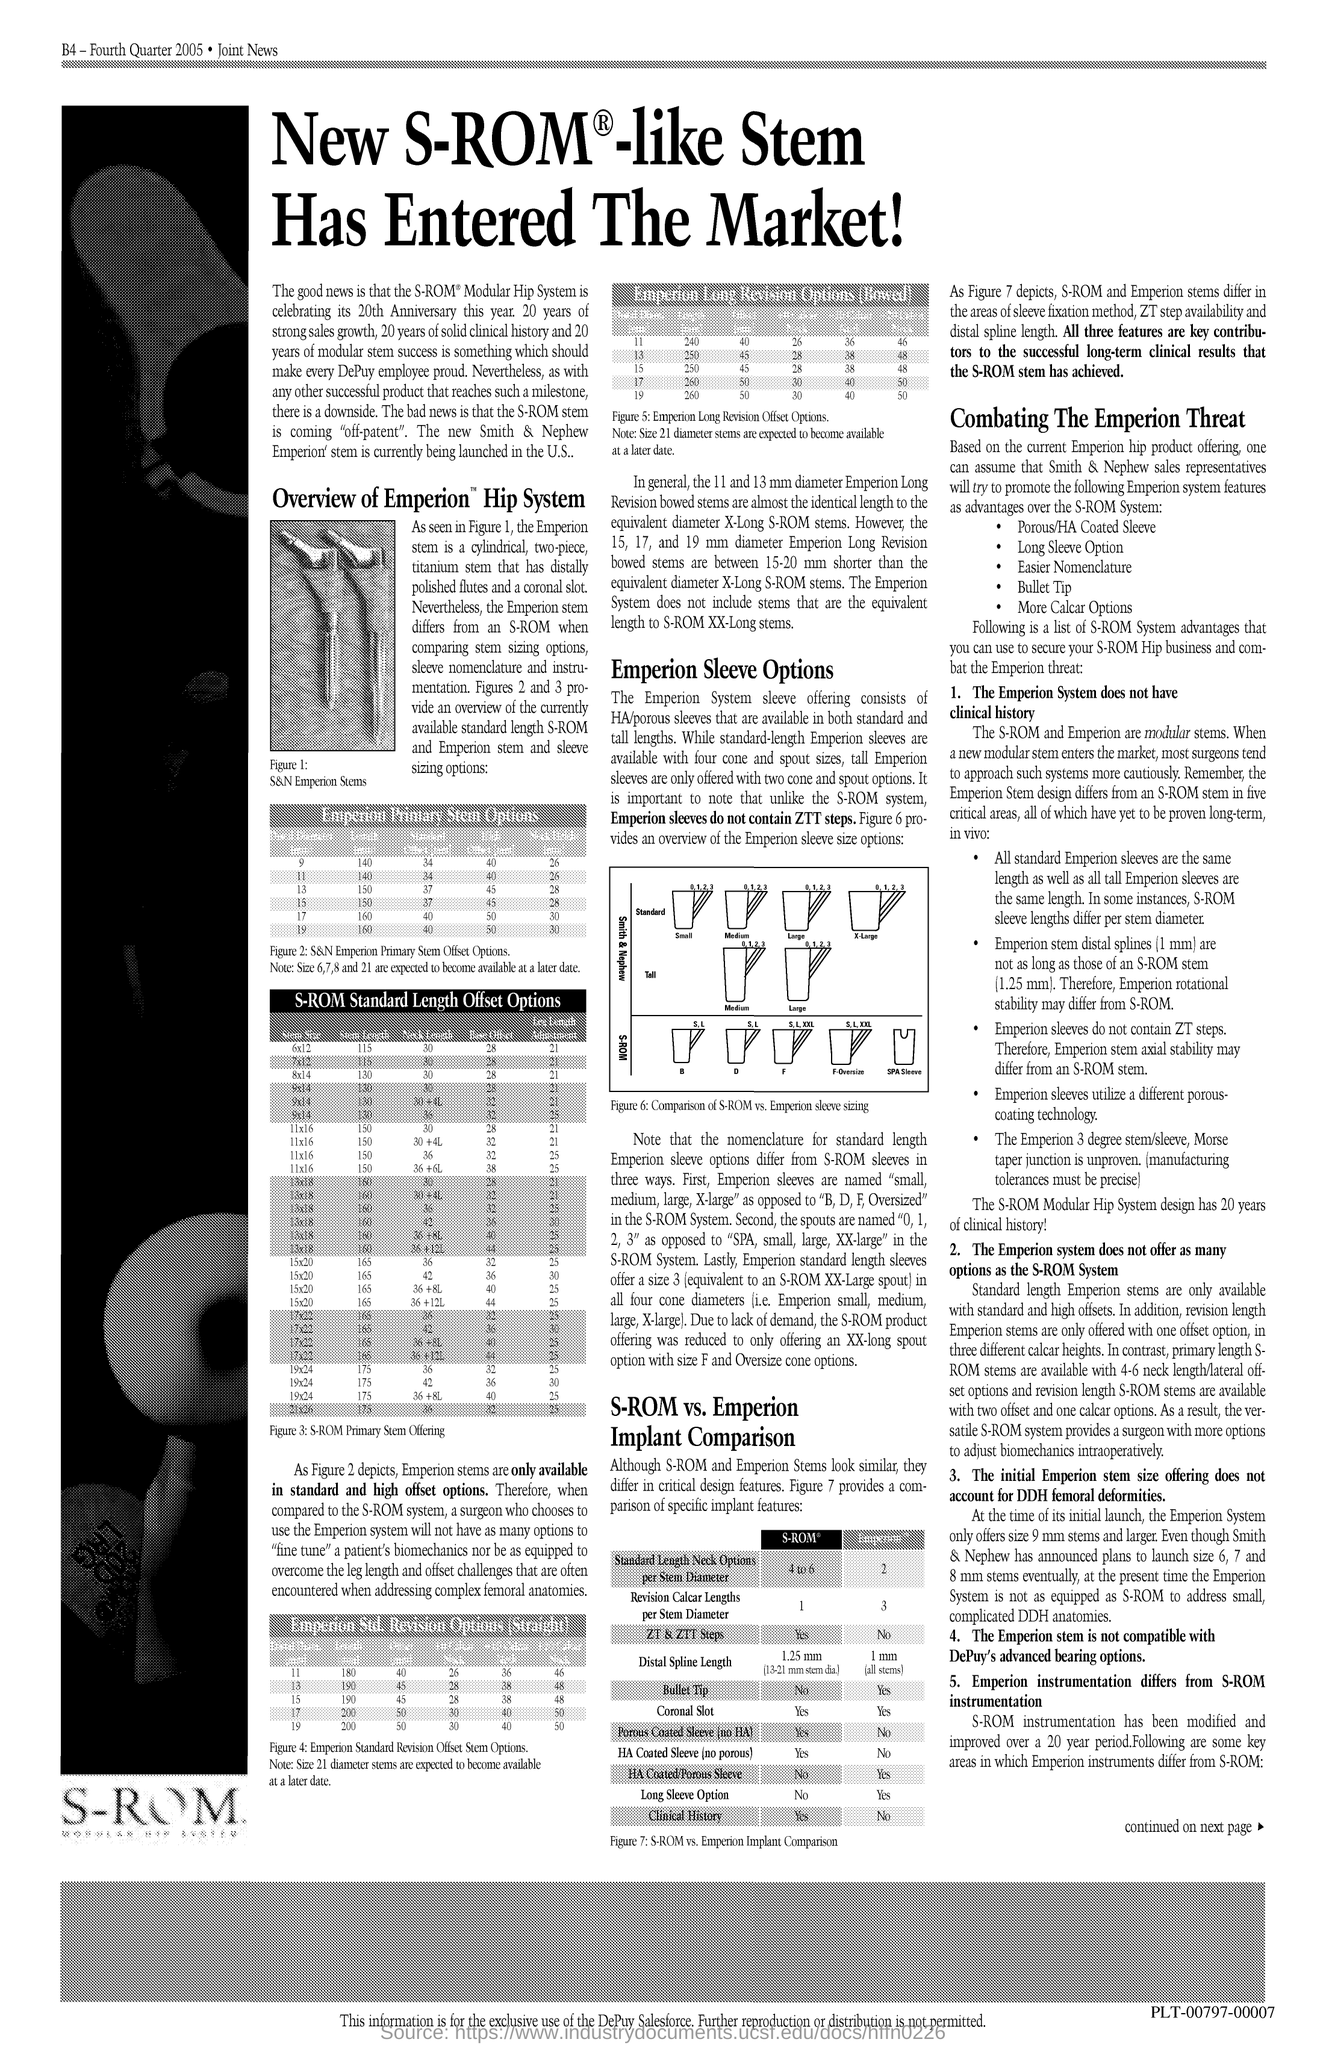Identify some key points in this picture. The text written directly below the left side image is S-ROM. 